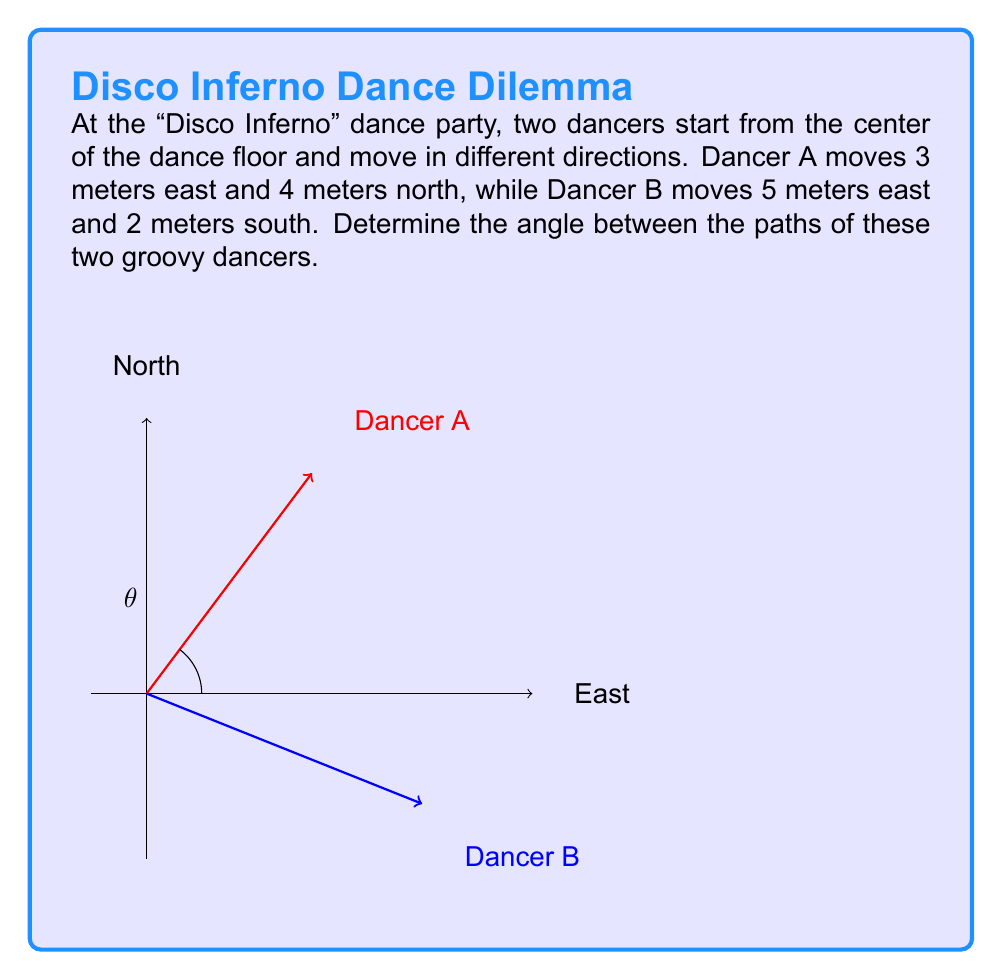Help me with this question. Let's break this down step-by-step:

1) First, we need to represent the paths of the dancers as vectors:
   Dancer A: $\vec{a} = \langle 3, 4 \rangle$
   Dancer B: $\vec{b} = \langle 5, -2 \rangle$

2) To find the angle between two vectors, we can use the dot product formula:
   $$\cos \theta = \frac{\vec{a} \cdot \vec{b}}{|\vec{a}||\vec{b}|}$$

3) Let's calculate the dot product $\vec{a} \cdot \vec{b}$:
   $\vec{a} \cdot \vec{b} = (3)(5) + (4)(-2) = 15 - 8 = 7$

4) Now, let's calculate the magnitudes of the vectors:
   $|\vec{a}| = \sqrt{3^2 + 4^2} = \sqrt{25} = 5$
   $|\vec{b}| = \sqrt{5^2 + (-2)^2} = \sqrt{29}$

5) Substituting into the formula:
   $$\cos \theta = \frac{7}{5\sqrt{29}}$$

6) To get $\theta$, we need to take the inverse cosine (arccos) of both sides:
   $$\theta = \arccos(\frac{7}{5\sqrt{29}})$$

7) Using a calculator, we can compute this value:
   $\theta \approx 1.249$ radians

8) Converting to degrees:
   $\theta \approx 1.249 \times \frac{180}{\pi} \approx 71.57°$
Answer: $71.57°$ 